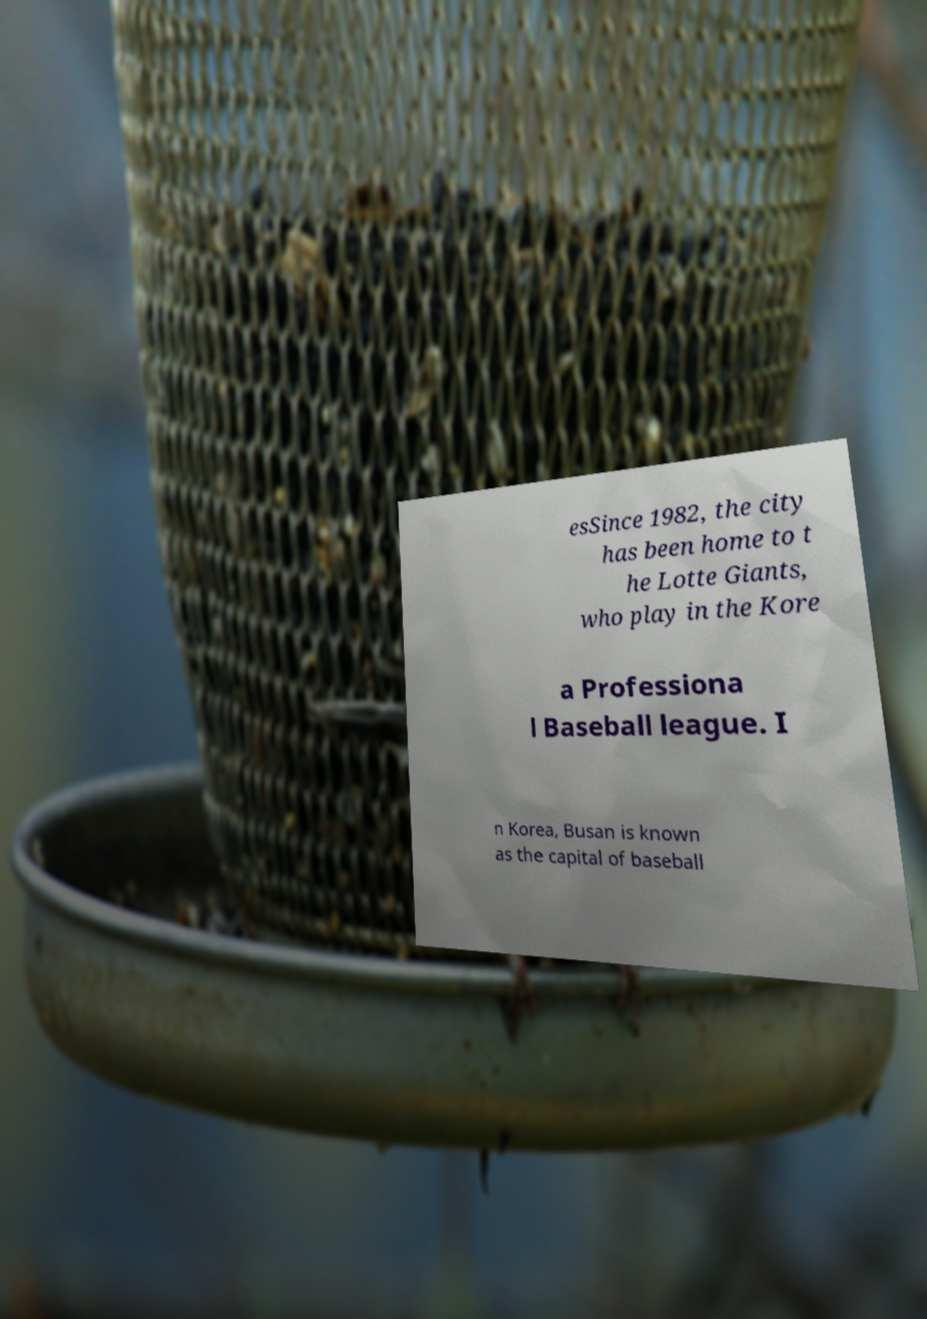Can you accurately transcribe the text from the provided image for me? esSince 1982, the city has been home to t he Lotte Giants, who play in the Kore a Professiona l Baseball league. I n Korea, Busan is known as the capital of baseball 